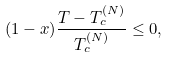Convert formula to latex. <formula><loc_0><loc_0><loc_500><loc_500>( 1 - x ) \frac { T - T _ { c } ^ { ( N ) } } { T _ { c } ^ { ( N ) } } \leq 0 ,</formula> 